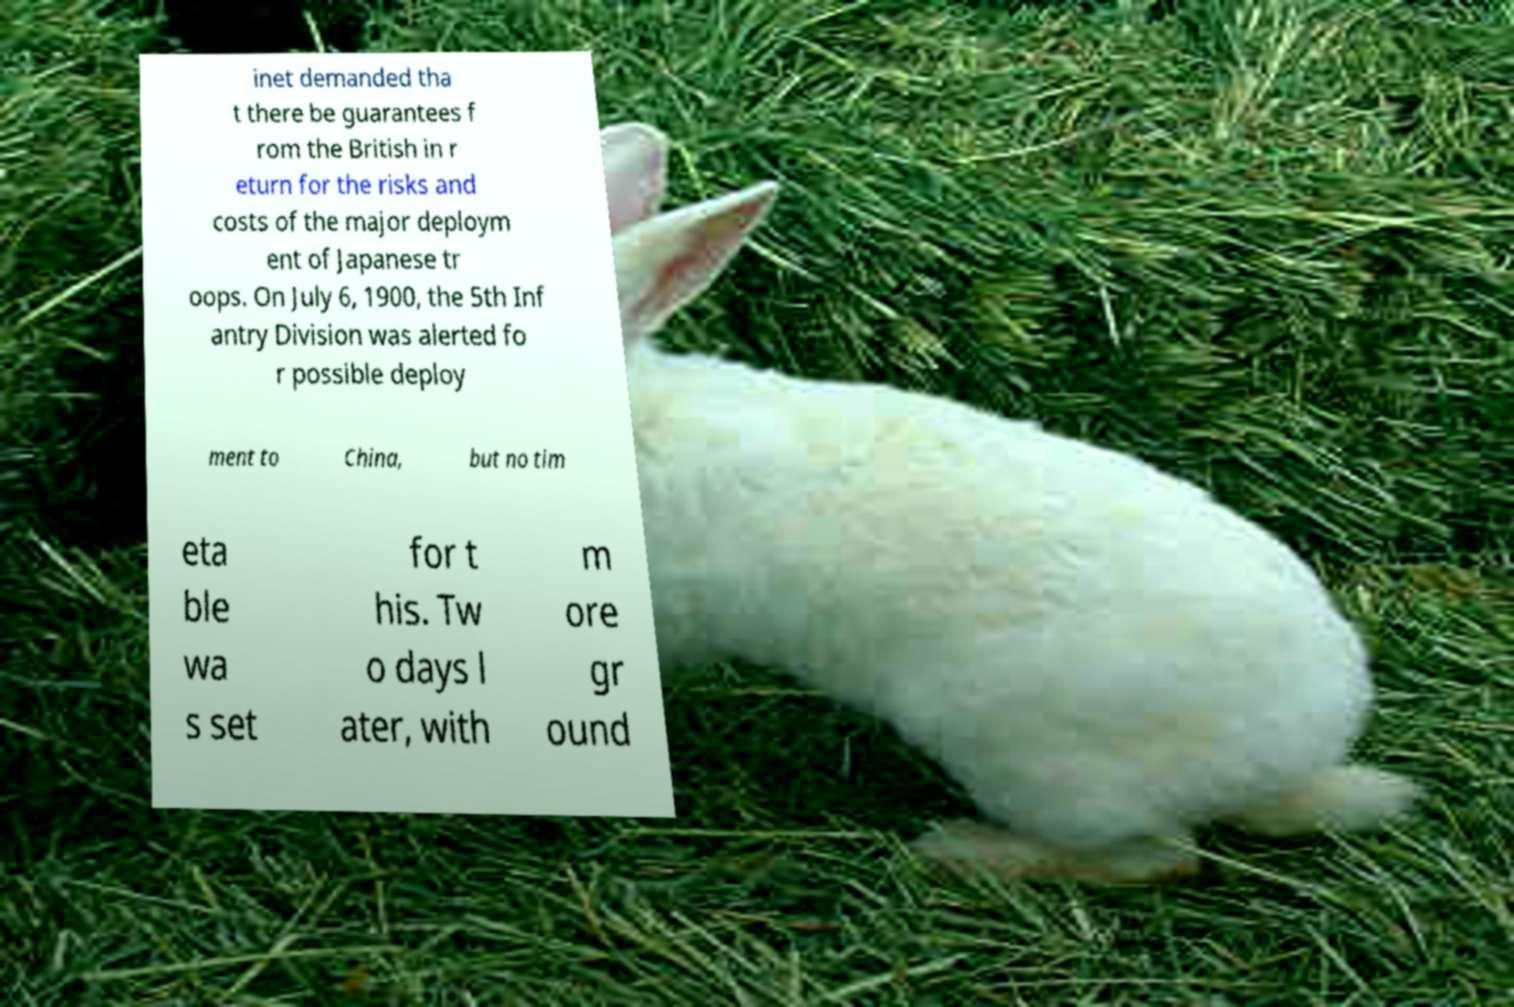Please identify and transcribe the text found in this image. inet demanded tha t there be guarantees f rom the British in r eturn for the risks and costs of the major deploym ent of Japanese tr oops. On July 6, 1900, the 5th Inf antry Division was alerted fo r possible deploy ment to China, but no tim eta ble wa s set for t his. Tw o days l ater, with m ore gr ound 